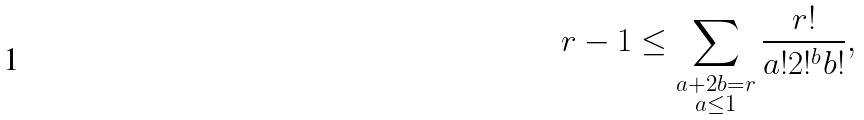Convert formula to latex. <formula><loc_0><loc_0><loc_500><loc_500>r - 1 \leq \sum _ { \substack { a + 2 b = r \\ a \leq 1 } } \frac { r ! } { a ! 2 ! ^ { b } b ! } ,</formula> 